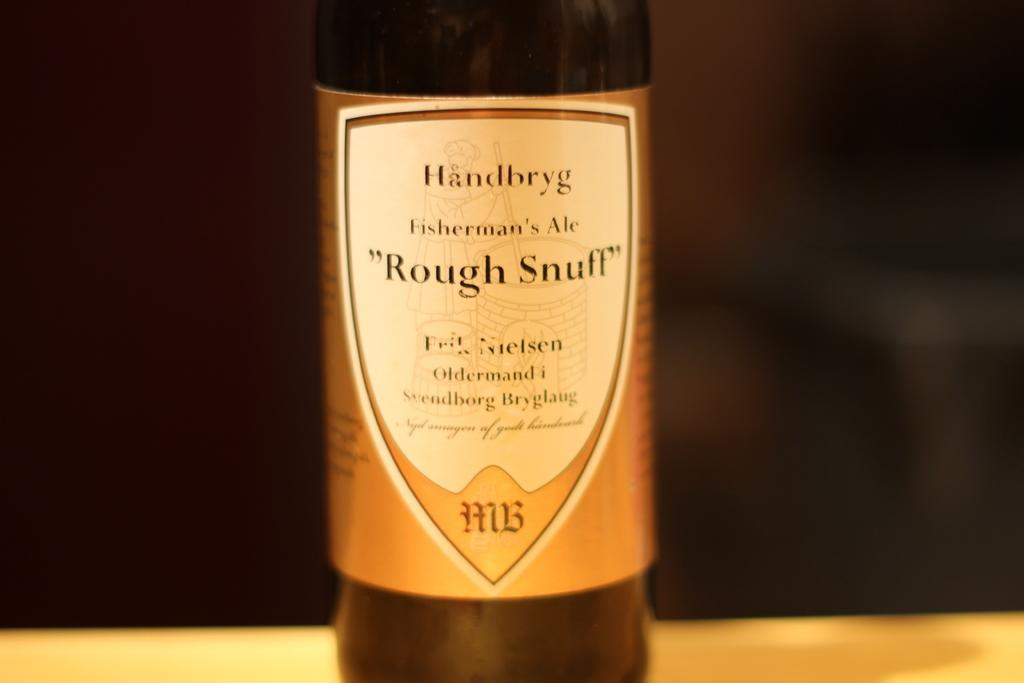<image>
Render a clear and concise summary of the photo. The label on a bottle reads, "Fisherman's Ale, Rough Stuff." 